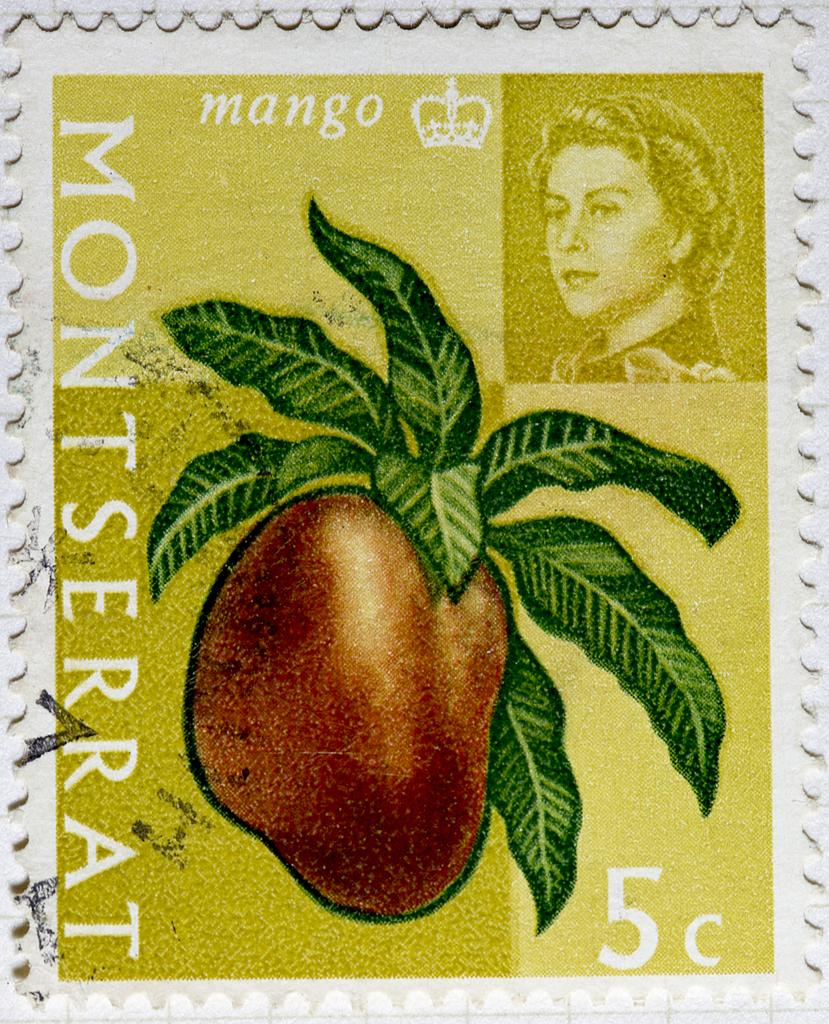What is present on the poster in the image? The poster contains text and images. Can you describe the content of the poster in more detail? Unfortunately, the specific content of the poster cannot be determined from the provided facts. How does the toothbrush help with the cough in the image? There is no toothbrush or cough present in the image; the image only contains a poster with text and images. 